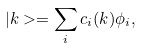Convert formula to latex. <formula><loc_0><loc_0><loc_500><loc_500>| { k } > = \sum _ { i } c _ { i } ( { k } ) \phi _ { i } ,</formula> 